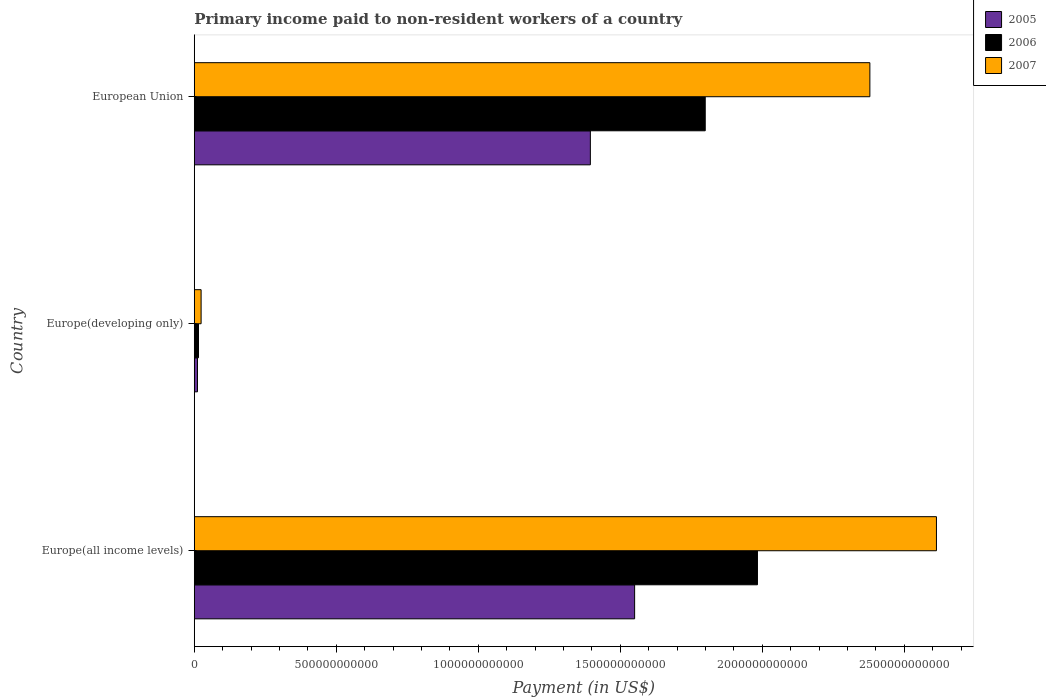How many different coloured bars are there?
Your response must be concise. 3. How many groups of bars are there?
Your response must be concise. 3. Are the number of bars on each tick of the Y-axis equal?
Offer a very short reply. Yes. What is the label of the 3rd group of bars from the top?
Provide a short and direct response. Europe(all income levels). In how many cases, is the number of bars for a given country not equal to the number of legend labels?
Ensure brevity in your answer.  0. What is the amount paid to workers in 2006 in European Union?
Offer a very short reply. 1.80e+12. Across all countries, what is the maximum amount paid to workers in 2007?
Provide a succinct answer. 2.61e+12. Across all countries, what is the minimum amount paid to workers in 2006?
Offer a very short reply. 1.49e+1. In which country was the amount paid to workers in 2006 maximum?
Make the answer very short. Europe(all income levels). In which country was the amount paid to workers in 2006 minimum?
Provide a short and direct response. Europe(developing only). What is the total amount paid to workers in 2006 in the graph?
Your answer should be very brief. 3.80e+12. What is the difference between the amount paid to workers in 2005 in Europe(all income levels) and that in European Union?
Offer a very short reply. 1.56e+11. What is the difference between the amount paid to workers in 2005 in Europe(all income levels) and the amount paid to workers in 2006 in European Union?
Offer a very short reply. -2.49e+11. What is the average amount paid to workers in 2005 per country?
Your answer should be compact. 9.86e+11. What is the difference between the amount paid to workers in 2006 and amount paid to workers in 2005 in European Union?
Your answer should be very brief. 4.04e+11. What is the ratio of the amount paid to workers in 2005 in Europe(all income levels) to that in Europe(developing only)?
Offer a terse response. 136.67. What is the difference between the highest and the second highest amount paid to workers in 2005?
Ensure brevity in your answer.  1.56e+11. What is the difference between the highest and the lowest amount paid to workers in 2006?
Keep it short and to the point. 1.97e+12. Is the sum of the amount paid to workers in 2006 in Europe(developing only) and European Union greater than the maximum amount paid to workers in 2007 across all countries?
Give a very brief answer. No. What does the 2nd bar from the top in European Union represents?
Provide a succinct answer. 2006. Is it the case that in every country, the sum of the amount paid to workers in 2007 and amount paid to workers in 2006 is greater than the amount paid to workers in 2005?
Provide a succinct answer. Yes. Are all the bars in the graph horizontal?
Ensure brevity in your answer.  Yes. How many countries are there in the graph?
Give a very brief answer. 3. What is the difference between two consecutive major ticks on the X-axis?
Make the answer very short. 5.00e+11. Are the values on the major ticks of X-axis written in scientific E-notation?
Provide a short and direct response. No. Does the graph contain any zero values?
Your answer should be compact. No. Does the graph contain grids?
Keep it short and to the point. No. What is the title of the graph?
Your response must be concise. Primary income paid to non-resident workers of a country. Does "1973" appear as one of the legend labels in the graph?
Ensure brevity in your answer.  No. What is the label or title of the X-axis?
Keep it short and to the point. Payment (in US$). What is the label or title of the Y-axis?
Offer a terse response. Country. What is the Payment (in US$) in 2005 in Europe(all income levels)?
Keep it short and to the point. 1.55e+12. What is the Payment (in US$) in 2006 in Europe(all income levels)?
Your response must be concise. 1.98e+12. What is the Payment (in US$) of 2007 in Europe(all income levels)?
Give a very brief answer. 2.61e+12. What is the Payment (in US$) of 2005 in Europe(developing only)?
Give a very brief answer. 1.13e+1. What is the Payment (in US$) in 2006 in Europe(developing only)?
Your answer should be compact. 1.49e+1. What is the Payment (in US$) of 2007 in Europe(developing only)?
Make the answer very short. 2.41e+1. What is the Payment (in US$) in 2005 in European Union?
Make the answer very short. 1.39e+12. What is the Payment (in US$) in 2006 in European Union?
Offer a terse response. 1.80e+12. What is the Payment (in US$) of 2007 in European Union?
Your response must be concise. 2.38e+12. Across all countries, what is the maximum Payment (in US$) of 2005?
Your response must be concise. 1.55e+12. Across all countries, what is the maximum Payment (in US$) in 2006?
Your answer should be very brief. 1.98e+12. Across all countries, what is the maximum Payment (in US$) in 2007?
Ensure brevity in your answer.  2.61e+12. Across all countries, what is the minimum Payment (in US$) of 2005?
Provide a succinct answer. 1.13e+1. Across all countries, what is the minimum Payment (in US$) of 2006?
Your answer should be compact. 1.49e+1. Across all countries, what is the minimum Payment (in US$) in 2007?
Your answer should be very brief. 2.41e+1. What is the total Payment (in US$) of 2005 in the graph?
Your response must be concise. 2.96e+12. What is the total Payment (in US$) of 2006 in the graph?
Your answer should be compact. 3.80e+12. What is the total Payment (in US$) of 2007 in the graph?
Keep it short and to the point. 5.02e+12. What is the difference between the Payment (in US$) in 2005 in Europe(all income levels) and that in Europe(developing only)?
Ensure brevity in your answer.  1.54e+12. What is the difference between the Payment (in US$) of 2006 in Europe(all income levels) and that in Europe(developing only)?
Provide a succinct answer. 1.97e+12. What is the difference between the Payment (in US$) of 2007 in Europe(all income levels) and that in Europe(developing only)?
Your answer should be very brief. 2.59e+12. What is the difference between the Payment (in US$) of 2005 in Europe(all income levels) and that in European Union?
Make the answer very short. 1.56e+11. What is the difference between the Payment (in US$) of 2006 in Europe(all income levels) and that in European Union?
Give a very brief answer. 1.84e+11. What is the difference between the Payment (in US$) of 2007 in Europe(all income levels) and that in European Union?
Make the answer very short. 2.34e+11. What is the difference between the Payment (in US$) of 2005 in Europe(developing only) and that in European Union?
Ensure brevity in your answer.  -1.38e+12. What is the difference between the Payment (in US$) of 2006 in Europe(developing only) and that in European Union?
Keep it short and to the point. -1.78e+12. What is the difference between the Payment (in US$) in 2007 in Europe(developing only) and that in European Union?
Provide a succinct answer. -2.35e+12. What is the difference between the Payment (in US$) of 2005 in Europe(all income levels) and the Payment (in US$) of 2006 in Europe(developing only)?
Your answer should be very brief. 1.54e+12. What is the difference between the Payment (in US$) of 2005 in Europe(all income levels) and the Payment (in US$) of 2007 in Europe(developing only)?
Your response must be concise. 1.53e+12. What is the difference between the Payment (in US$) in 2006 in Europe(all income levels) and the Payment (in US$) in 2007 in Europe(developing only)?
Provide a succinct answer. 1.96e+12. What is the difference between the Payment (in US$) in 2005 in Europe(all income levels) and the Payment (in US$) in 2006 in European Union?
Your response must be concise. -2.49e+11. What is the difference between the Payment (in US$) of 2005 in Europe(all income levels) and the Payment (in US$) of 2007 in European Union?
Your answer should be compact. -8.28e+11. What is the difference between the Payment (in US$) of 2006 in Europe(all income levels) and the Payment (in US$) of 2007 in European Union?
Your answer should be very brief. -3.96e+11. What is the difference between the Payment (in US$) of 2005 in Europe(developing only) and the Payment (in US$) of 2006 in European Union?
Ensure brevity in your answer.  -1.79e+12. What is the difference between the Payment (in US$) in 2005 in Europe(developing only) and the Payment (in US$) in 2007 in European Union?
Offer a terse response. -2.37e+12. What is the difference between the Payment (in US$) in 2006 in Europe(developing only) and the Payment (in US$) in 2007 in European Union?
Your answer should be compact. -2.36e+12. What is the average Payment (in US$) of 2005 per country?
Make the answer very short. 9.86e+11. What is the average Payment (in US$) in 2006 per country?
Keep it short and to the point. 1.27e+12. What is the average Payment (in US$) of 2007 per country?
Your answer should be very brief. 1.67e+12. What is the difference between the Payment (in US$) in 2005 and Payment (in US$) in 2006 in Europe(all income levels)?
Keep it short and to the point. -4.33e+11. What is the difference between the Payment (in US$) in 2005 and Payment (in US$) in 2007 in Europe(all income levels)?
Provide a succinct answer. -1.06e+12. What is the difference between the Payment (in US$) in 2006 and Payment (in US$) in 2007 in Europe(all income levels)?
Ensure brevity in your answer.  -6.30e+11. What is the difference between the Payment (in US$) in 2005 and Payment (in US$) in 2006 in Europe(developing only)?
Offer a very short reply. -3.56e+09. What is the difference between the Payment (in US$) in 2005 and Payment (in US$) in 2007 in Europe(developing only)?
Your response must be concise. -1.28e+1. What is the difference between the Payment (in US$) of 2006 and Payment (in US$) of 2007 in Europe(developing only)?
Your answer should be compact. -9.20e+09. What is the difference between the Payment (in US$) of 2005 and Payment (in US$) of 2006 in European Union?
Ensure brevity in your answer.  -4.04e+11. What is the difference between the Payment (in US$) in 2005 and Payment (in US$) in 2007 in European Union?
Your answer should be very brief. -9.84e+11. What is the difference between the Payment (in US$) in 2006 and Payment (in US$) in 2007 in European Union?
Make the answer very short. -5.80e+11. What is the ratio of the Payment (in US$) of 2005 in Europe(all income levels) to that in Europe(developing only)?
Ensure brevity in your answer.  136.67. What is the ratio of the Payment (in US$) in 2006 in Europe(all income levels) to that in Europe(developing only)?
Your response must be concise. 133.08. What is the ratio of the Payment (in US$) in 2007 in Europe(all income levels) to that in Europe(developing only)?
Your answer should be compact. 108.43. What is the ratio of the Payment (in US$) in 2005 in Europe(all income levels) to that in European Union?
Offer a terse response. 1.11. What is the ratio of the Payment (in US$) in 2006 in Europe(all income levels) to that in European Union?
Provide a succinct answer. 1.1. What is the ratio of the Payment (in US$) of 2007 in Europe(all income levels) to that in European Union?
Make the answer very short. 1.1. What is the ratio of the Payment (in US$) of 2005 in Europe(developing only) to that in European Union?
Offer a very short reply. 0.01. What is the ratio of the Payment (in US$) in 2006 in Europe(developing only) to that in European Union?
Your response must be concise. 0.01. What is the ratio of the Payment (in US$) in 2007 in Europe(developing only) to that in European Union?
Offer a very short reply. 0.01. What is the difference between the highest and the second highest Payment (in US$) in 2005?
Ensure brevity in your answer.  1.56e+11. What is the difference between the highest and the second highest Payment (in US$) in 2006?
Your response must be concise. 1.84e+11. What is the difference between the highest and the second highest Payment (in US$) of 2007?
Your answer should be very brief. 2.34e+11. What is the difference between the highest and the lowest Payment (in US$) of 2005?
Provide a succinct answer. 1.54e+12. What is the difference between the highest and the lowest Payment (in US$) of 2006?
Give a very brief answer. 1.97e+12. What is the difference between the highest and the lowest Payment (in US$) in 2007?
Make the answer very short. 2.59e+12. 